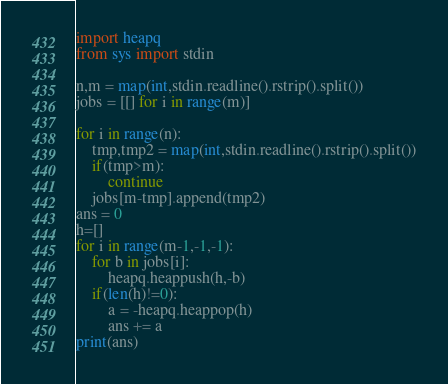<code> <loc_0><loc_0><loc_500><loc_500><_Python_>import heapq
from sys import stdin

n,m = map(int,stdin.readline().rstrip().split())
jobs = [[] for i in range(m)]

for i in range(n):
    tmp,tmp2 = map(int,stdin.readline().rstrip().split())
    if(tmp>m):
        continue
    jobs[m-tmp].append(tmp2)
ans = 0
h=[]
for i in range(m-1,-1,-1):
    for b in jobs[i]:
        heapq.heappush(h,-b)
    if(len(h)!=0):
        a = -heapq.heappop(h)
        ans += a
print(ans)</code> 